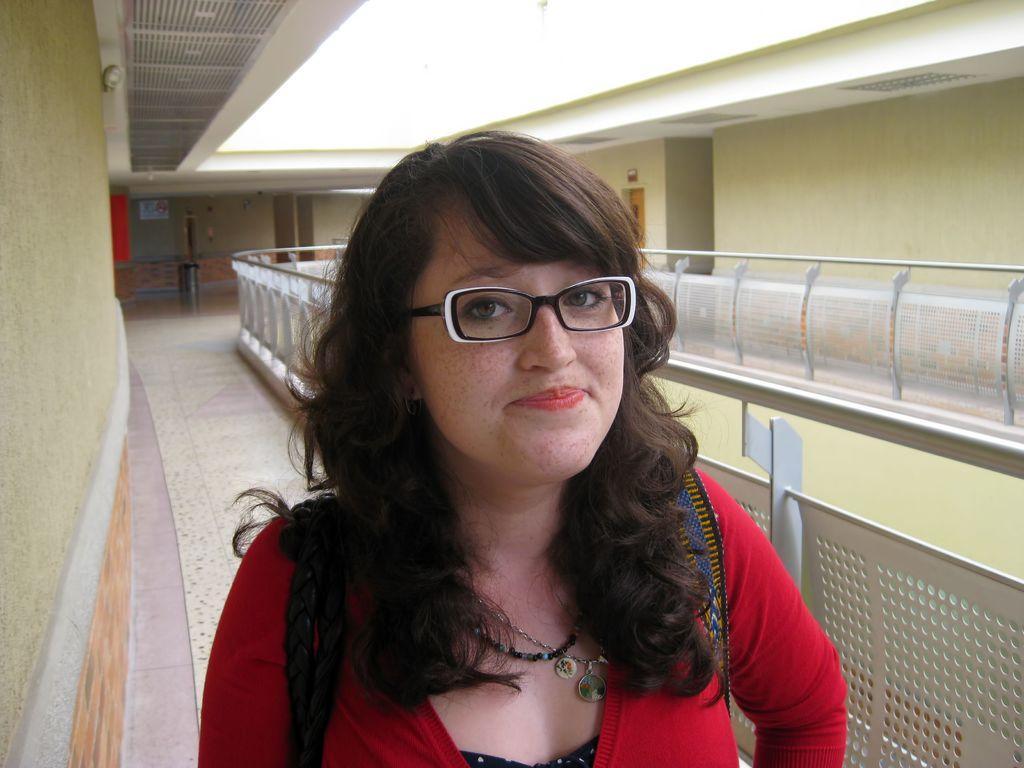Please provide a concise description of this image. In this image we can see a woman standing on the floor. In the background there are walls, doors, bins and railings. 